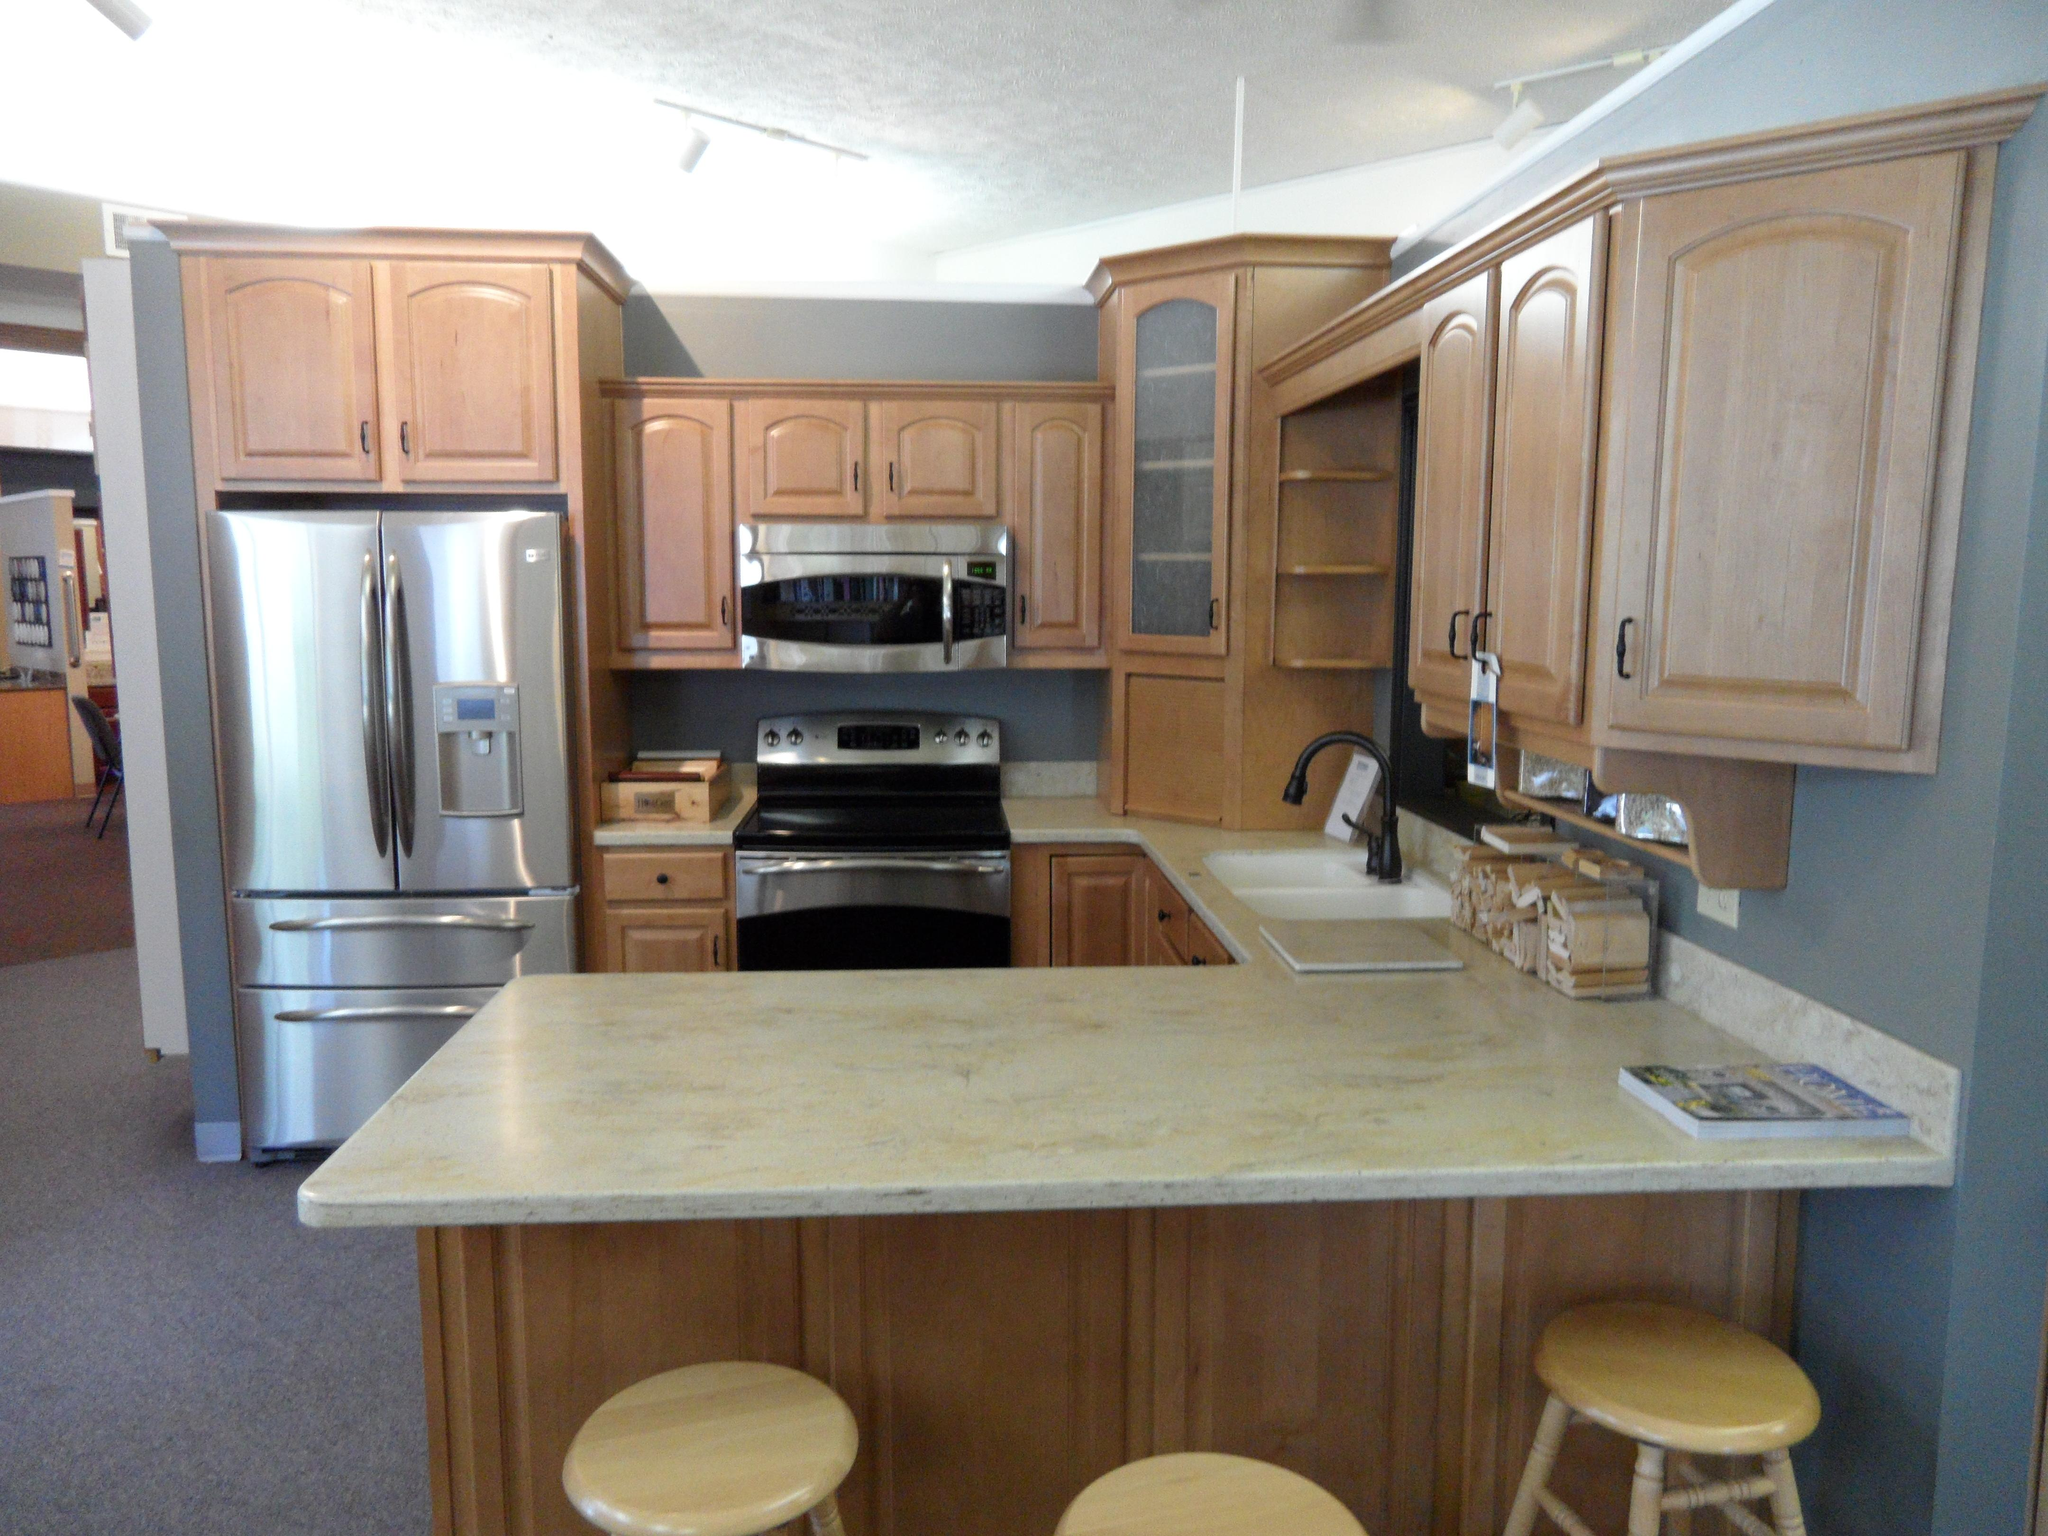What type of room is shown in the image? The image depicts a kitchen. What can be seen on the walls in the kitchen? There is a wall visible in the image. What type of office furniture is present on the stage in the image? There is no office furniture or stage present in the image; it depicts a kitchen with a visible wall. 